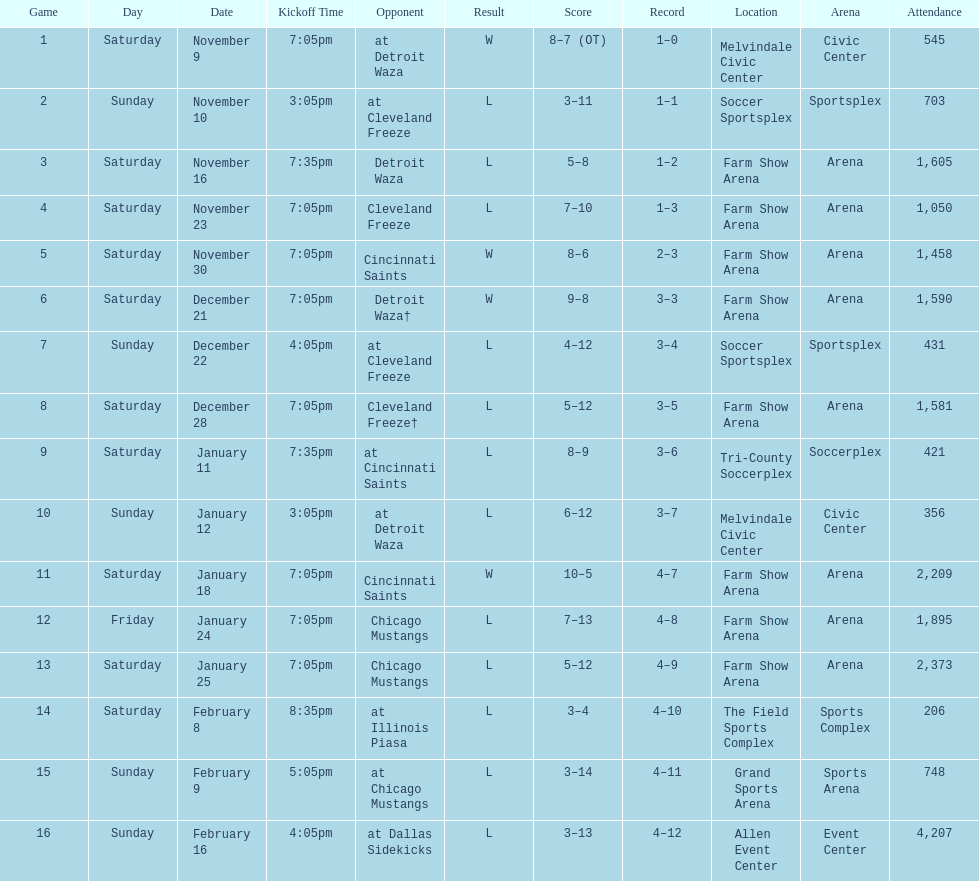How many games did the harrisburg heat lose to the cleveland freeze in total. 4. 